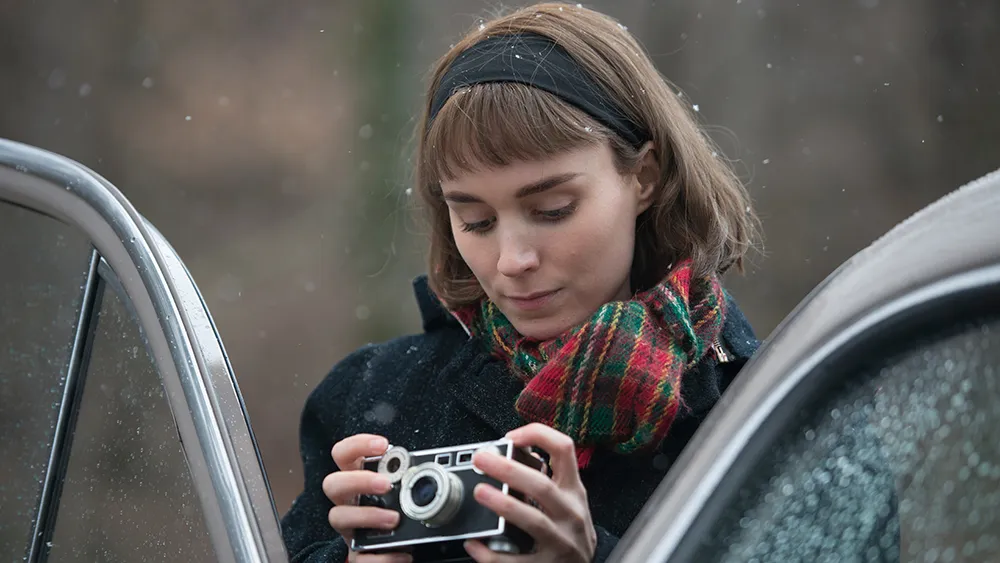Describe the following image. In the image, a woman is captured in a moment of quiet introspection. Dressed in a black coat, she stands next to a vintage car speckled with rain droplets, her attention focused on the classic camera she holds in her hands. A red and green plaid scarf adds a vibrant pop of color to her ensemble, with hues echoing the blurred woodland scenery in the background. Her hair, styled in a short bob, is neatly kept back by a black headband. The overall scene suggests a serene moment, possibly between takes on a film set, with the natural ambiance and soft lighting enhancing the calm and introspective mood. 